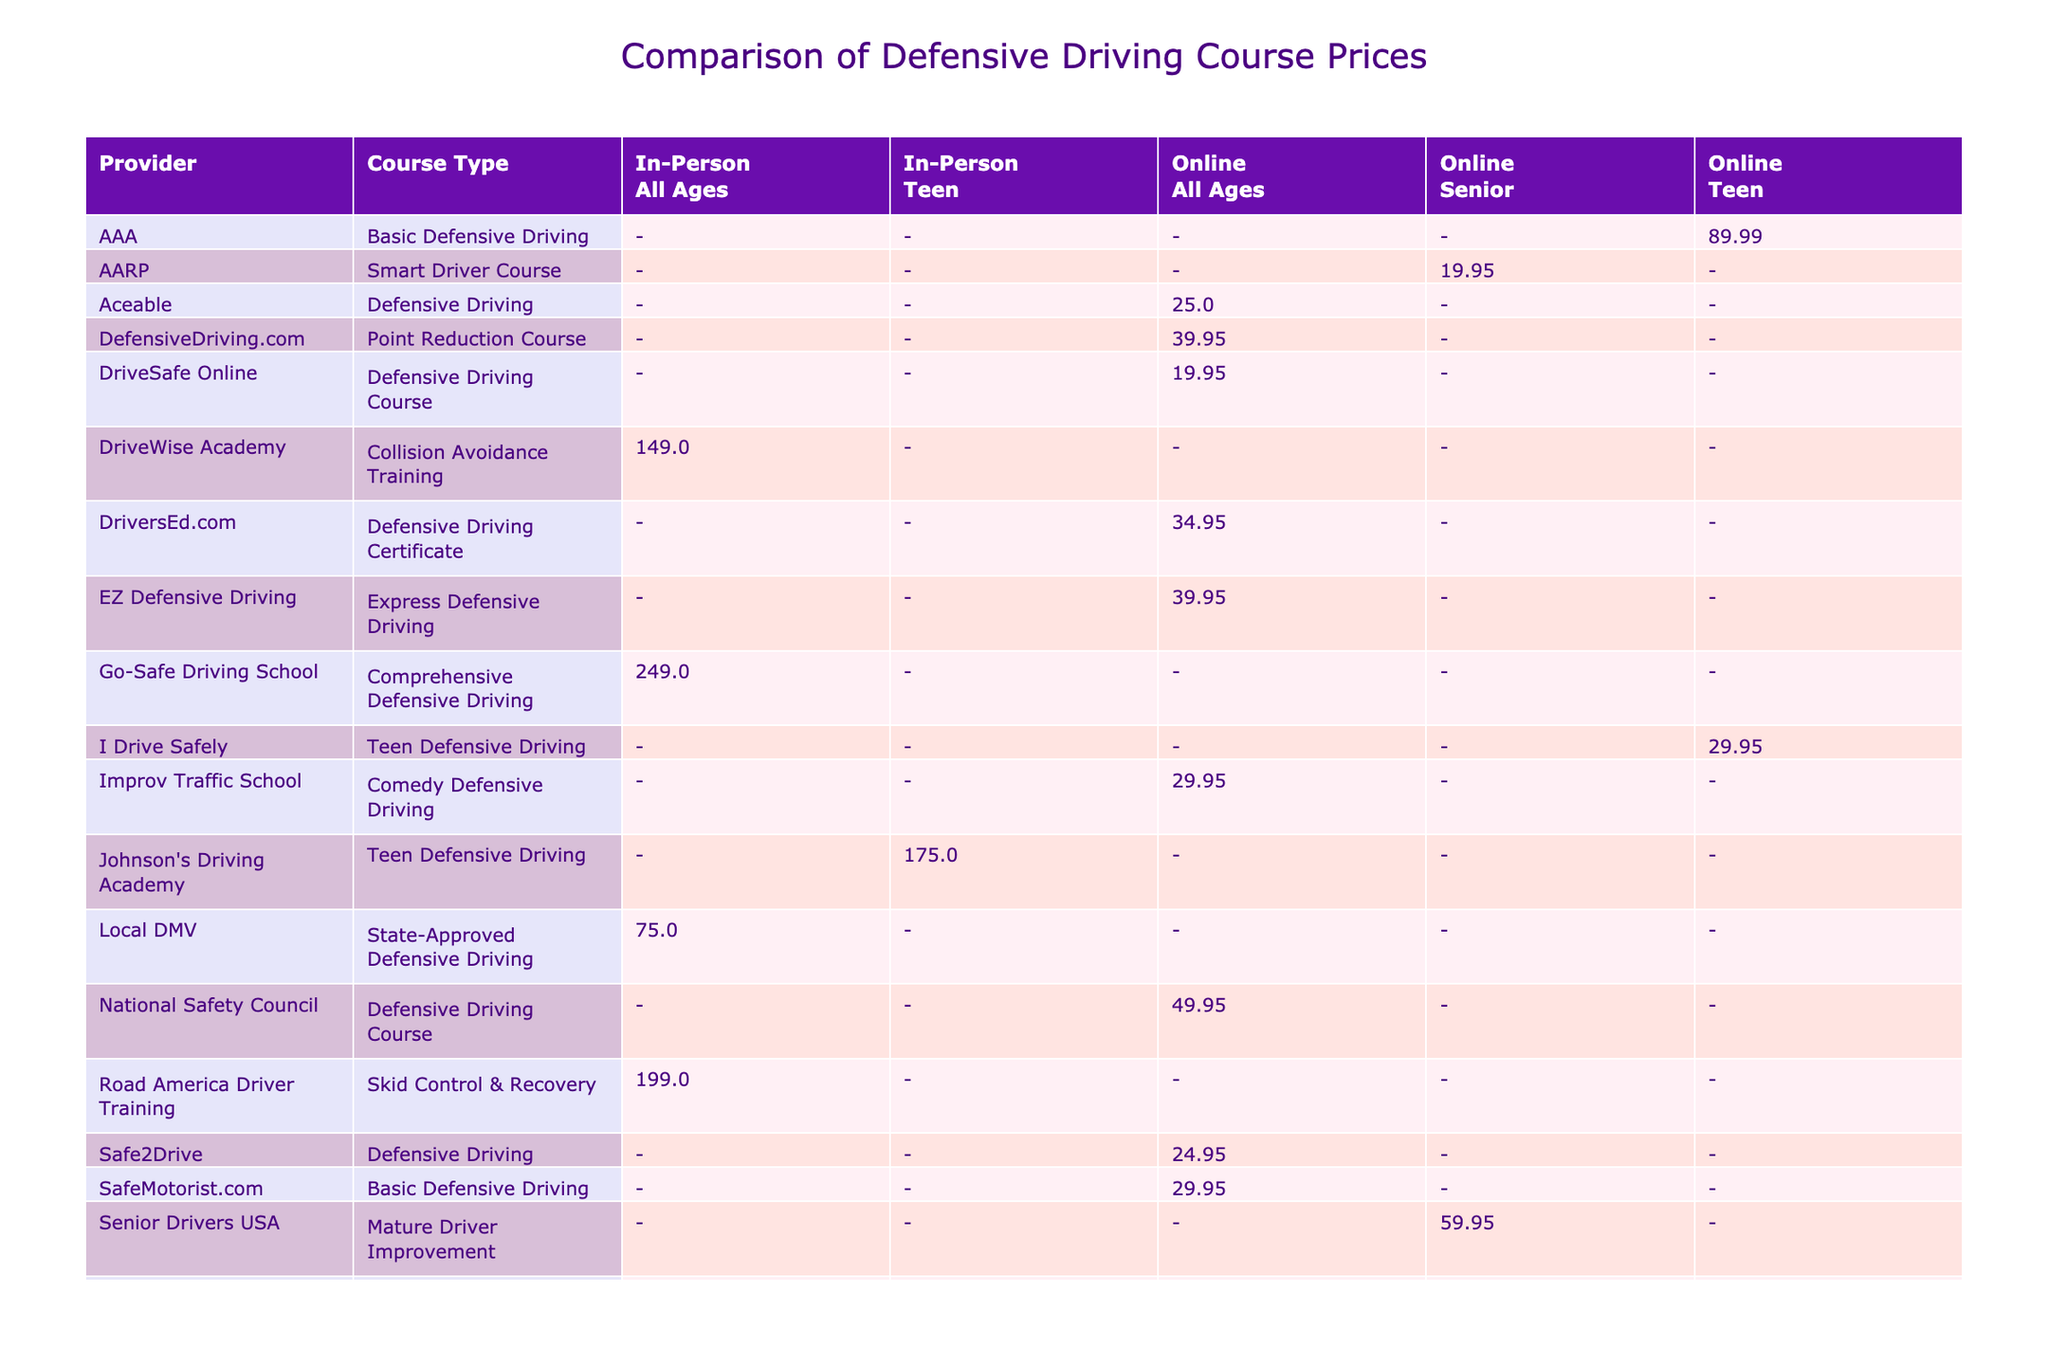What is the price of the advanced defensive driving course offered by Smith's Driving School? The table lists Smith's Driving School under the "Provider" and "Course Type" columns with a price of $199.00 for the "Advanced Defensive Driving" course.
Answer: $199.00 Which provider offers the lowest-priced online defensive driving course? By checking the prices for online courses in the table, the lowest price is found under DriversEd.com at $34.95 for the "Defensive Driving Certificate".
Answer: $34.95 Is there any course that is both online and aimed at teenagers? Looking through the table, there are multiple entries for online courses aimed at teenagers, specifically "Teen Defensive Driving" from I Drive Safely, priced at $29.95 and another one from AAA for $89.99.
Answer: Yes What is the average price of the courses offered by online providers? To find the average price, we sum the prices of all online courses (89.99 + 49.95 + 34.95 + 19.95 + 19.95 + 29.95 + 25.00 + 24.95 + 29.95 + 19.95 + 59.95 + 99.99 + 29.95 + 39.95) = $  649.90. There are 14 online courses, so the average is 649.90 / 14 = 46.42.
Answer: $46.42 What is the total duration of the advanced defensive driving courses available? The advanced courses in the table are from Smith's Driving School (12 hours) and YouTuber's Recommended Course (8 hours). Summing these gives 12 + 8 = 20 hours as the total duration.
Answer: 20 hours 